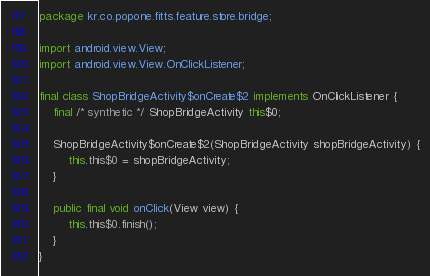Convert code to text. <code><loc_0><loc_0><loc_500><loc_500><_Java_>package kr.co.popone.fitts.feature.store.bridge;

import android.view.View;
import android.view.View.OnClickListener;

final class ShopBridgeActivity$onCreate$2 implements OnClickListener {
    final /* synthetic */ ShopBridgeActivity this$0;

    ShopBridgeActivity$onCreate$2(ShopBridgeActivity shopBridgeActivity) {
        this.this$0 = shopBridgeActivity;
    }

    public final void onClick(View view) {
        this.this$0.finish();
    }
}
</code> 